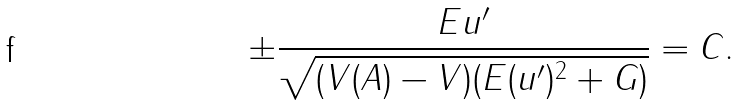<formula> <loc_0><loc_0><loc_500><loc_500>\pm \frac { E u ^ { \prime } } { \sqrt { ( V ( A ) - V ) ( E ( u ^ { \prime } ) ^ { 2 } + G ) } } = C .</formula> 